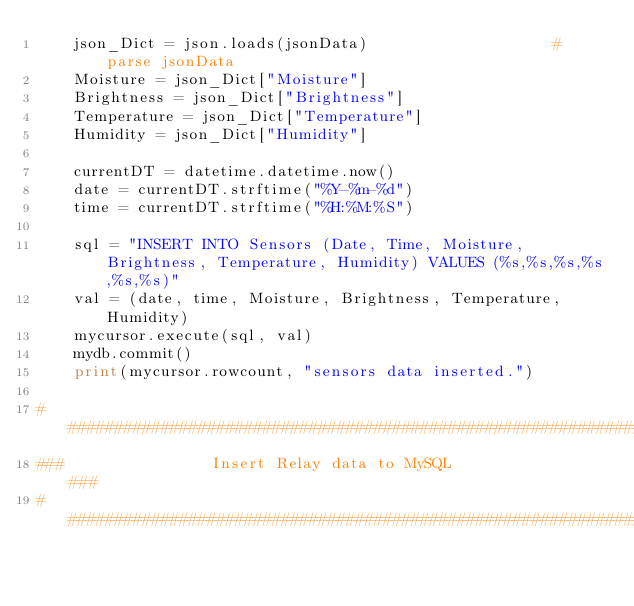Convert code to text. <code><loc_0><loc_0><loc_500><loc_500><_Python_>    json_Dict = json.loads(jsonData)                    # parse jsonData
    Moisture = json_Dict["Moisture"]
    Brightness = json_Dict["Brightness"]
    Temperature = json_Dict["Temperature"]
    Humidity = json_Dict["Humidity"]

    currentDT = datetime.datetime.now()
    date = currentDT.strftime("%Y-%m-%d")
    time = currentDT.strftime("%H:%M:%S")

    sql = "INSERT INTO Sensors (Date, Time, Moisture, Brightness, Temperature, Humidity) VALUES (%s,%s,%s,%s,%s,%s)"
    val = (date, time, Moisture, Brightness, Temperature, Humidity)
    mycursor.execute(sql, val)
    mydb.commit()
    print(mycursor.rowcount, "sensors data inserted.")

################################################################
###                Insert Relay data to MySQL               ###
################################################################</code> 